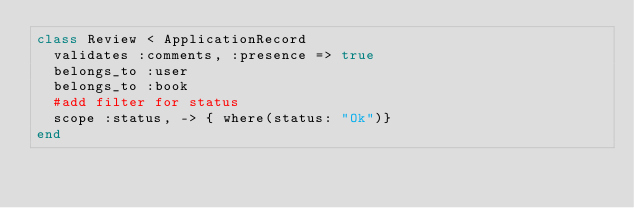<code> <loc_0><loc_0><loc_500><loc_500><_Ruby_>class Review < ApplicationRecord
  validates :comments, :presence => true
  belongs_to :user
  belongs_to :book 
  #add filter for status 
  scope :status, -> { where(status: "Ok")}
end
</code> 